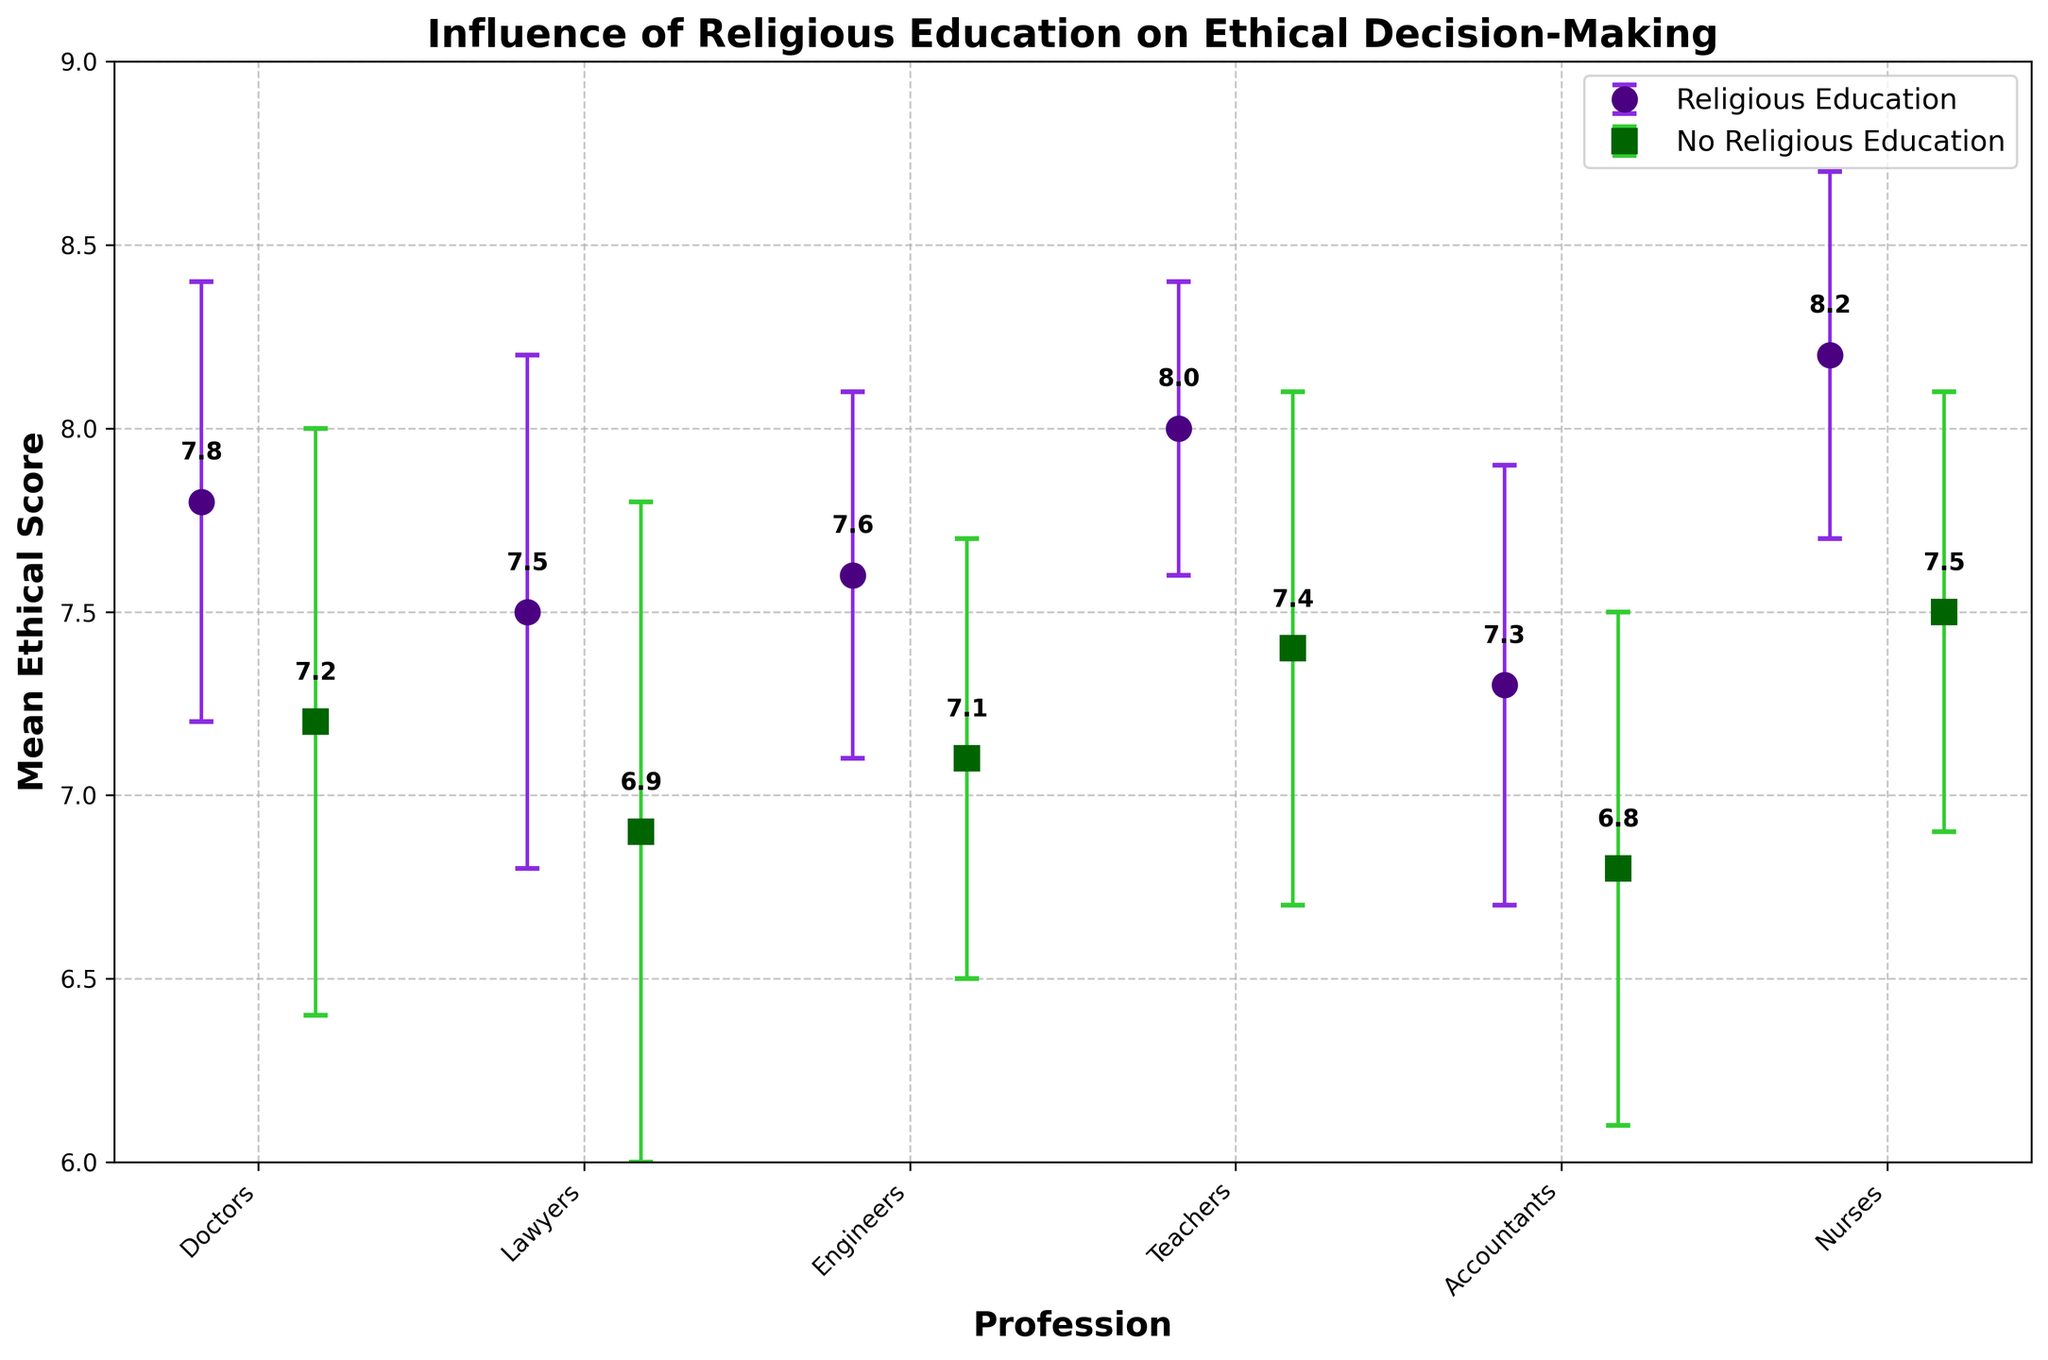What is the title of the figure? The title of the figure is located at the top and describes the overall purpose or theme of the plot. By looking at the top of the figure, we can identify it.
Answer: Influence of Religious Education on Ethical Decision-Making What is the ethical score range for teachers with religious education compared to those without religious education? The plot shows the mean ethical scores with error bars indicating standard deviation. For teachers with religious education, the mean score and error bars are shown on the left side of their x-position. For those without, it is on the right side. By comparing these, we observe the scores.
Answer: 8.0 vs. 7.4 Which profession shows the largest difference in mean ethical scores between those with and without religious education? To determine the profession with the largest difference, we look at the mean ethical scores for each profession. By subtracting the score of non-religious education from the score of religious education, the largest difference becomes apparent.
Answer: Nurses What is the mean ethical score for engineers with no religious education, and how does it compare to engineers with religious education? By checking the positions for engineers along the x-axis and noting the mean ethical scores given, we compare the two values. Engineers with religious education have their data marked separately from those without.
Answer: 7.1, which is 0.5 lower than those with religious education Are there any professions where the ethical scores do not overlap between those with and without religious education based on the error bars? Examining each profession's error bars, we check if the error bars for religious and non-religious scores overlap. Lack of overlap indicates a clear difference in scores without intersecting confidence intervals.
Answer: Teachers and Accountants What is the highest ethical score observed, and which group does it belong to? We identify the highest dot on the y-axis. The group's label (point shape and color) indicates whether it is associated with religious education or not.
Answer: 8.2, Nurses with religious education How many professions have an average ethical score higher than 7.5 for individuals with religious education? We count the number of points representing religious education (colored dots on the left side) that are positioned above the 7.5 mark on the y-axis.
Answer: 5 professions What is the approximate difference in ethical scores between doctors with religious education and nurses with no religious education? By noting the mean ethical scores for both groups (religious doctors and non-religious nurses) and calculating the difference, this can be determined.
Answer: 0.3 Which group has the lowest mean ethical score? We locate the lowest point on the plot along the y-axis and note its associated group (shape and color).
Answer: Accountants with no religious education Are the standard deviations for doctors with and without religious education larger or smaller compared to each other? We look at the error bars (representing standard deviation) for doctors with and without religious education and compare their lengths.
Answer: Larger for doctors without religious education 